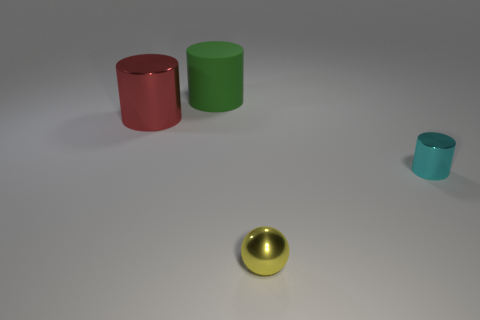Add 1 large rubber things. How many objects exist? 5 Subtract all spheres. How many objects are left? 3 Subtract 0 blue cylinders. How many objects are left? 4 Subtract all matte blocks. Subtract all yellow shiny objects. How many objects are left? 3 Add 4 big green things. How many big green things are left? 5 Add 2 big rubber things. How many big rubber things exist? 3 